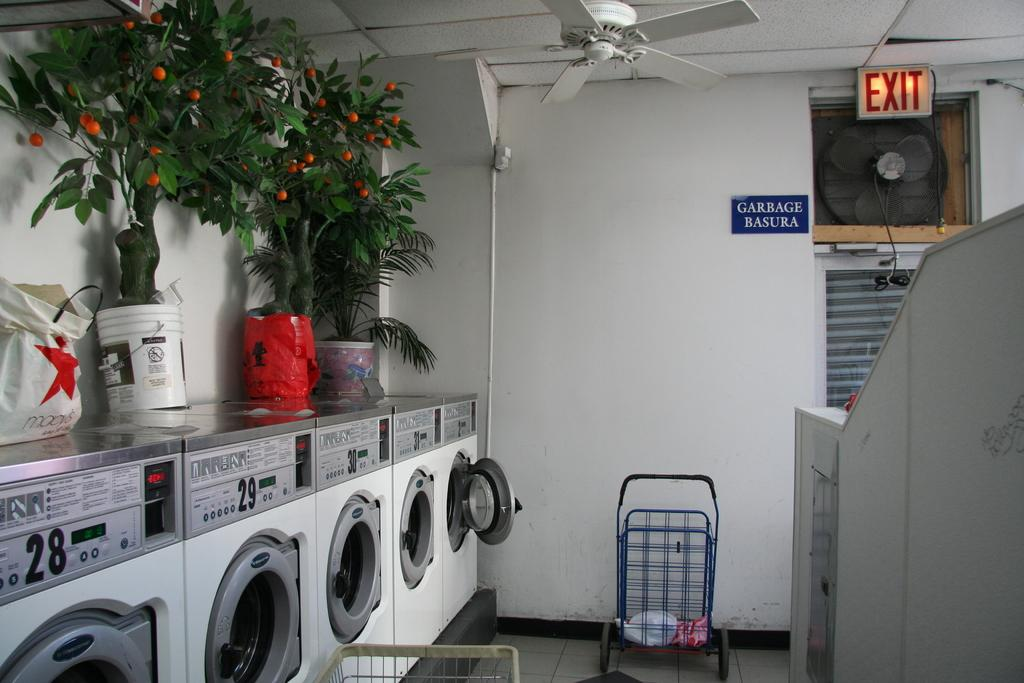<image>
Share a concise interpretation of the image provided. a laundromat with a red exit sign on the top right corner 